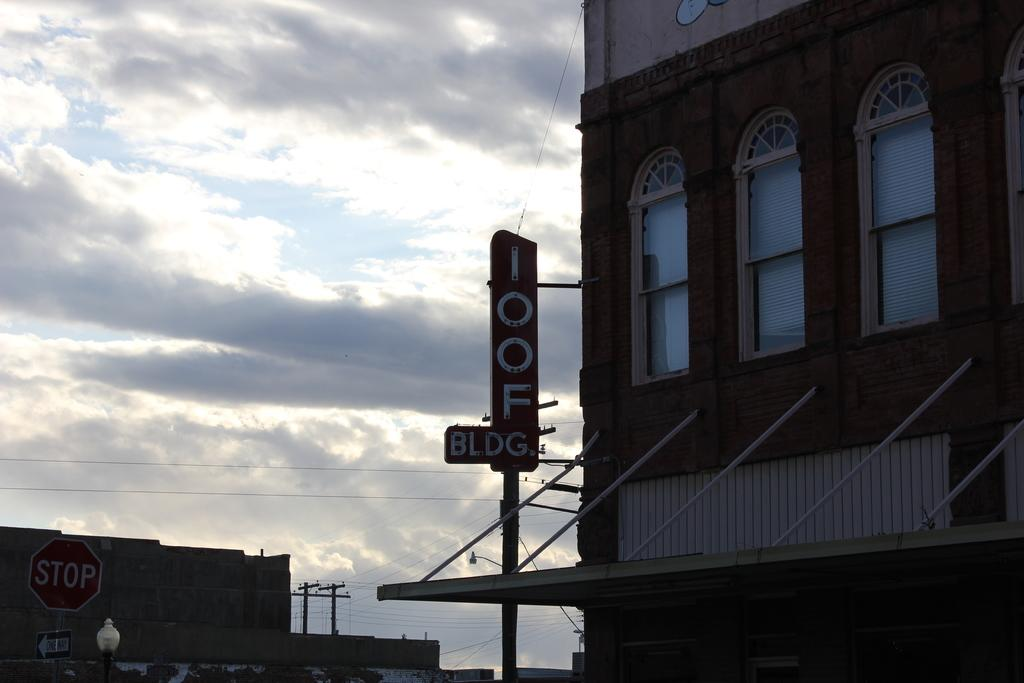What is the main object in the image? There is a name board in the image. What other objects can be seen in the image? There are sign boards, poles, wires, buildings, windows, and a light visible in the image. What is the condition of the sky in the background of the image? The sky with clouds is visible in the background of the image. How many spiders are crawling on the name board in the image? There are no spiders visible on the name board or anywhere else in the image. What type of butter is being used to write on the sign boards in the image? There is no butter present in the image, and the sign boards do not have any writing on them. 